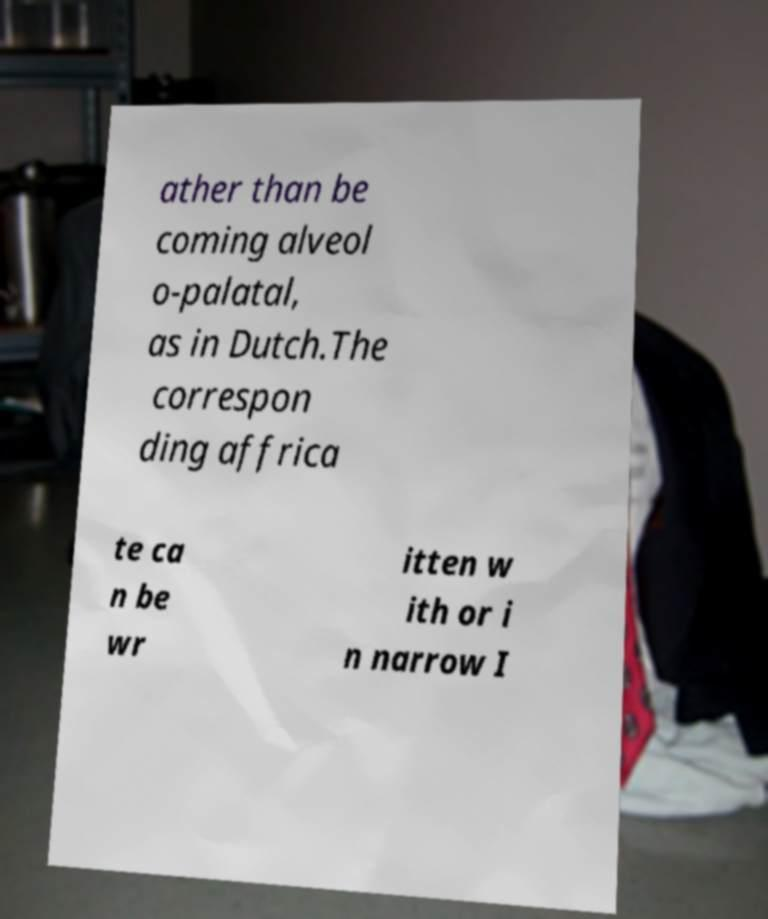Could you extract and type out the text from this image? ather than be coming alveol o-palatal, as in Dutch.The correspon ding affrica te ca n be wr itten w ith or i n narrow I 